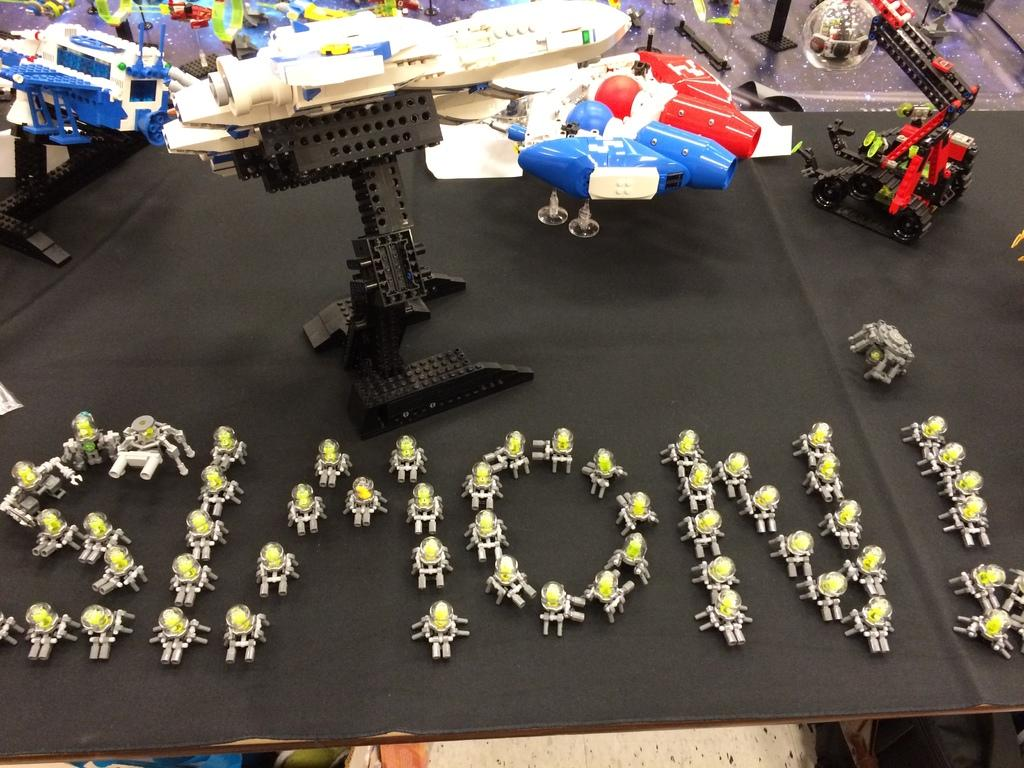What type of objects can be seen in the image? There are many toys in the image. Can you identify any specific toys in the image? Yes, Transformers and Lego toys are visible in the image. What is the surface on which the toys are placed? The toys are on a black mat. What type of meat is being prepared on the canvas in the image? There is no canvas or meat present in the image; it features toys on a black mat. Is the queen present in the image? There is no queen or any reference to royalty in the image; it features toys on a black mat. 